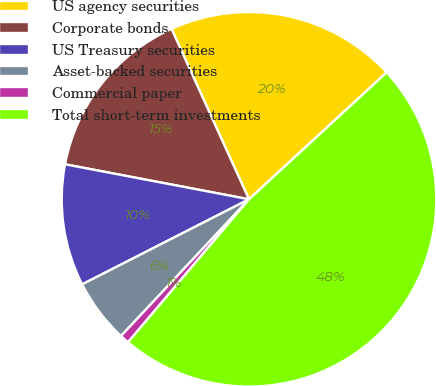Convert chart. <chart><loc_0><loc_0><loc_500><loc_500><pie_chart><fcel>US agency securities<fcel>Corporate bonds<fcel>US Treasury securities<fcel>Asset-backed securities<fcel>Commercial paper<fcel>Total short-term investments<nl><fcel>19.94%<fcel>15.22%<fcel>10.5%<fcel>5.52%<fcel>0.8%<fcel>48.03%<nl></chart> 